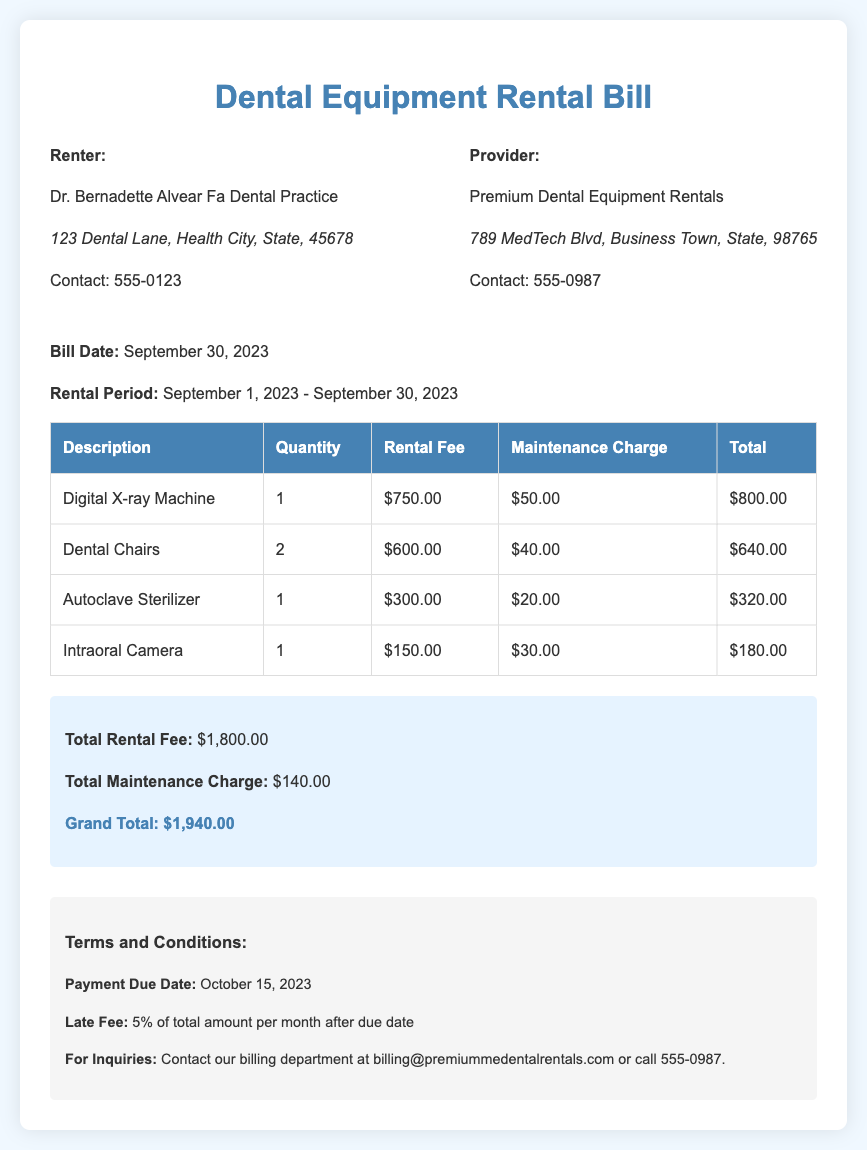What is the name of the renter? The renter's name is listed at the top of the document and is "Dr. Bernadette Alvear Fa Dental Practice."
Answer: Dr. Bernadette Alvear Fa Dental Practice What is the bill date? The bill date is mentioned specifically in the document for when the bill was created.
Answer: September 30, 2023 How many dental chairs were rented? The quantity of dental chairs rented is provided in the table section of the document.
Answer: 2 What is the total rental fee? The total rental fee is the cumulative sum of the rental fees indicated in the breakdown, provided at the end of the document.
Answer: $1,800.00 What is the maintenance charge for the autoclave sterilizer? The specific maintenance charge for the autoclave sterilizer is detailed in the breakdown table.
Answer: $20.00 What is the grand total amount due? The grand total is summarized at the bottom of the document, combining all fees.
Answer: $1,940.00 What is the late fee percentage per month after the due date? The late fee percentage is specifically mentioned in the terms and conditions section of the document.
Answer: 5% What is the payment due date? The payment due date is clearly stated in the terms section of the document.
Answer: October 15, 2023 What is the contact number for the provider? The contact number for the provider is specified in the provider's section of the document.
Answer: 555-0987 